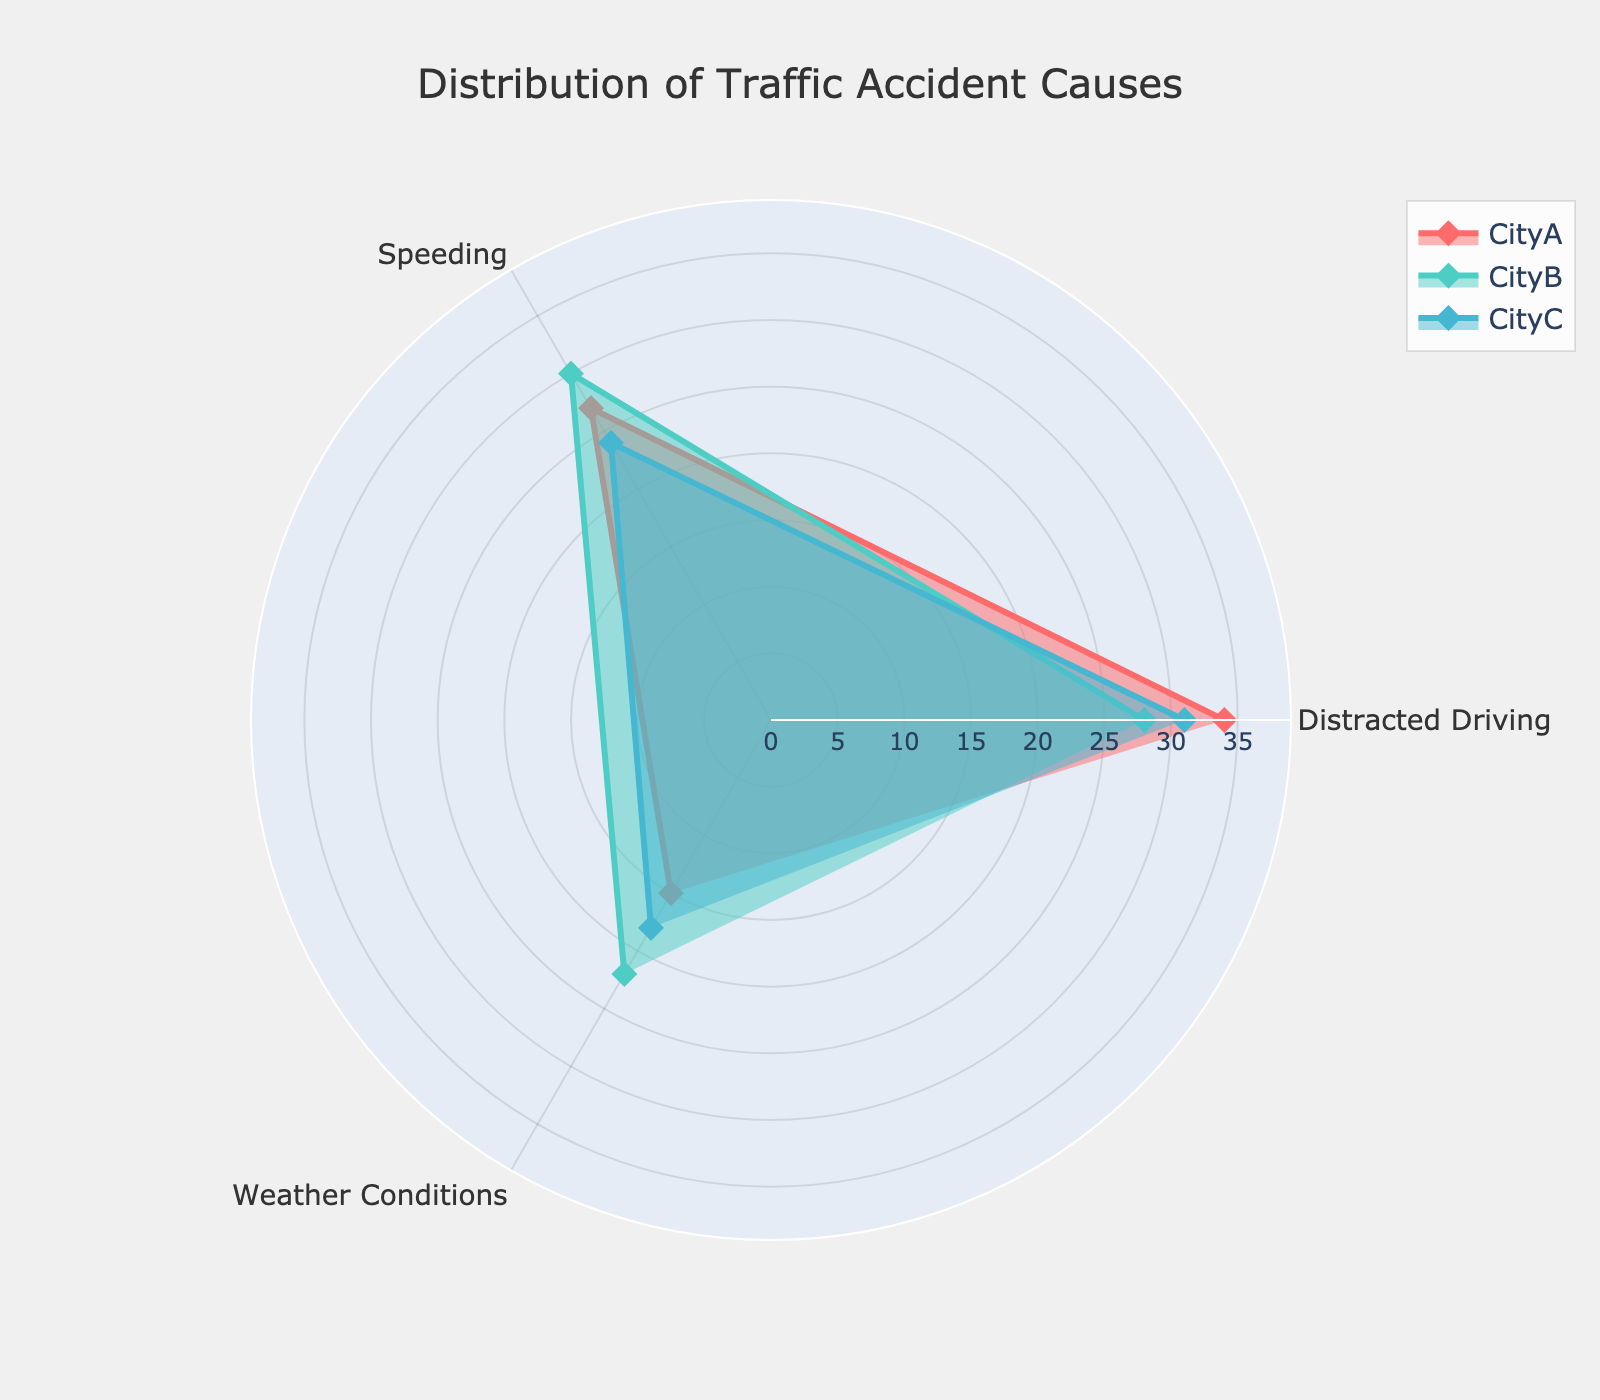Which city has the highest count of accidents due to distracted driving? By looking at the radar chart, you can compare the data points for "Distracted Driving" category. City A has a count of 34, City B has 28, and City C has 31. City A has the highest count.
Answer: City A Which cause of accidents has the lowest count in City B? To find this, compare the data points for City B in all categories. Distracted Driving is 28, Speeding is 30, and Weather Conditions is 22. The lowest count is for Weather Conditions.
Answer: Weather Conditions How many more accidents are due to speeding in City B compared to City C? To determine this, subtract the count of speeding accidents in City C (24) from the count in City B (30). The difference is 30 - 24 = 6.
Answer: 6 What is the average count of weather condition-related accidents across all cities? Add the counts for Weather Conditions across City A (15), City B (22), and City C (18). The sum is 15 + 22 + 18 = 55. Divide this by the number of cities, which is 3. So, 55 / 3 ≈ 18.33.
Answer: ~18.33 Which city has the most even distribution of accident causes? By observing the radar chart, compare the consistency of each city's data points along different categories. City C has data points that are closer to each other (31, 24, 18) compared to the variation in City A (34, 27, 15) and City B (28, 30, 22).
Answer: City C What is the total number of accidents in City A from all causes? Add up the counts from City A for all causes: 34 (Distracted Driving) + 27 (Speeding) + 15 (Weather Conditions). The sum is 34 + 27 + 15 = 76.
Answer: 76 Which traffic accident cause shows the greatest variation across the three cities? To determine this, compare the ranges for each cause across the three cities. Distracted Driving ranges from 28 to 34 (a range of 6), Speeding ranges from 24 to 30 (a range of 6), and Weather Conditions ranges from 15 to 22 (a range of 7). Weather Conditions has the greatest variation.
Answer: Weather Conditions Among the given causes, which city has the highest overall accidents? By summing the counts for each city, City A: 34 + 27 + 15 = 76, City B: 28 + 30 + 22 = 80, City C: 31 + 24 + 18 = 73. City B has the highest total.
Answer: City B 